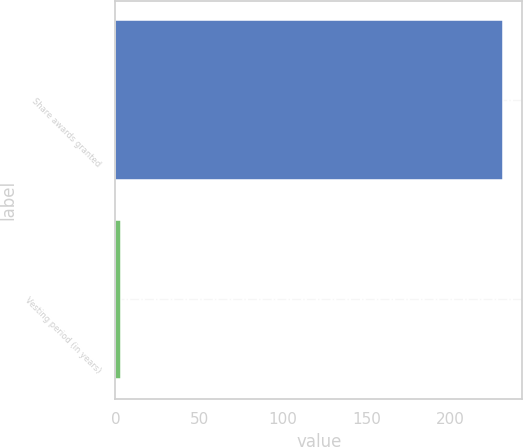<chart> <loc_0><loc_0><loc_500><loc_500><bar_chart><fcel>Share awards granted<fcel>Vesting period (in years)<nl><fcel>231<fcel>3<nl></chart> 